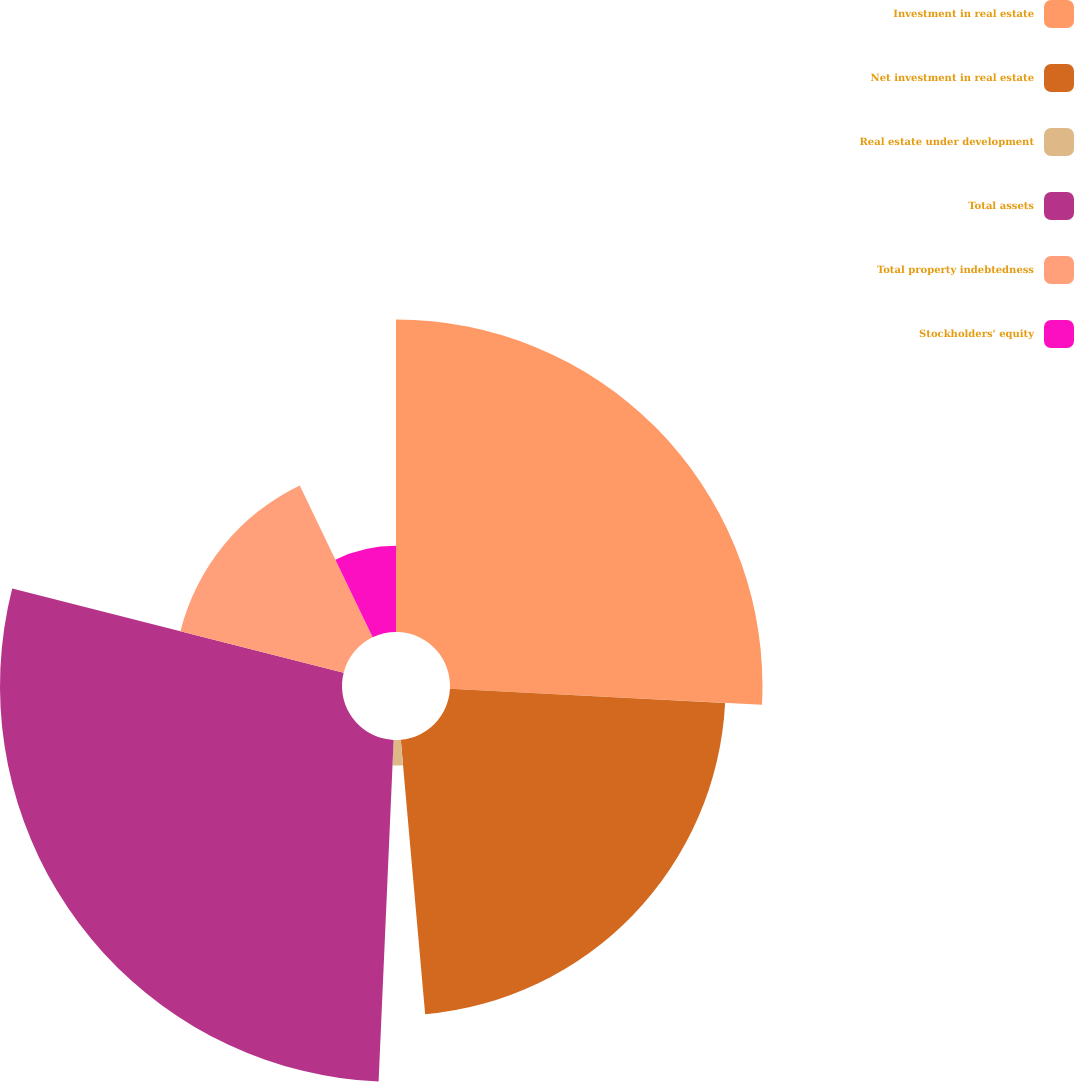Convert chart. <chart><loc_0><loc_0><loc_500><loc_500><pie_chart><fcel>Investment in real estate<fcel>Net investment in real estate<fcel>Real estate under development<fcel>Total assets<fcel>Total property indebtedness<fcel>Stockholders' equity<nl><fcel>25.82%<fcel>22.77%<fcel>2.11%<fcel>28.26%<fcel>13.92%<fcel>7.12%<nl></chart> 